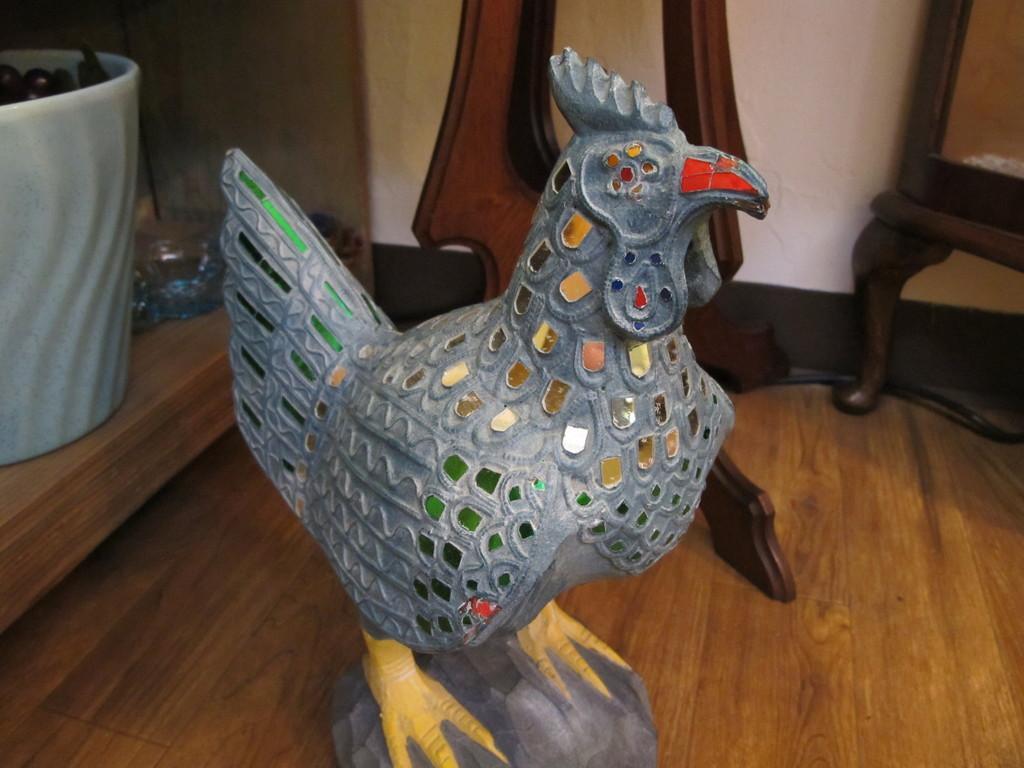How would you summarize this image in a sentence or two? In this image we can see the sculpture of a bird on a stone on the floor and on the left side we can see items in a bucket on a rack and we can see a stand and chair on the floor and we can see the wall. 